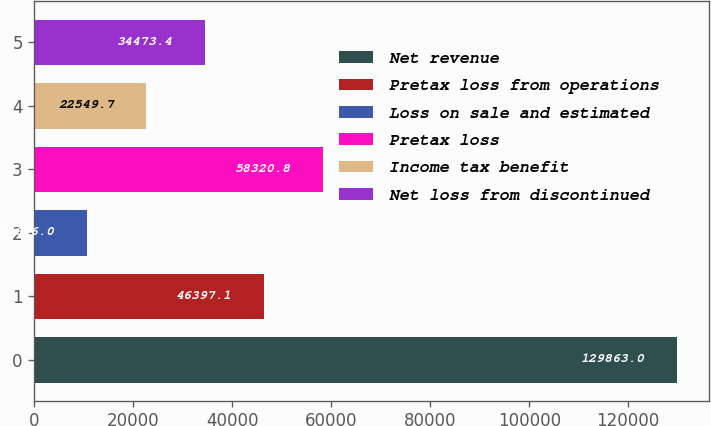<chart> <loc_0><loc_0><loc_500><loc_500><bar_chart><fcel>Net revenue<fcel>Pretax loss from operations<fcel>Loss on sale and estimated<fcel>Pretax loss<fcel>Income tax benefit<fcel>Net loss from discontinued<nl><fcel>129863<fcel>46397.1<fcel>10626<fcel>58320.8<fcel>22549.7<fcel>34473.4<nl></chart> 